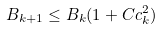<formula> <loc_0><loc_0><loc_500><loc_500>B _ { k + 1 } \leq B _ { k } ( 1 + C c _ { k } ^ { 2 } )</formula> 